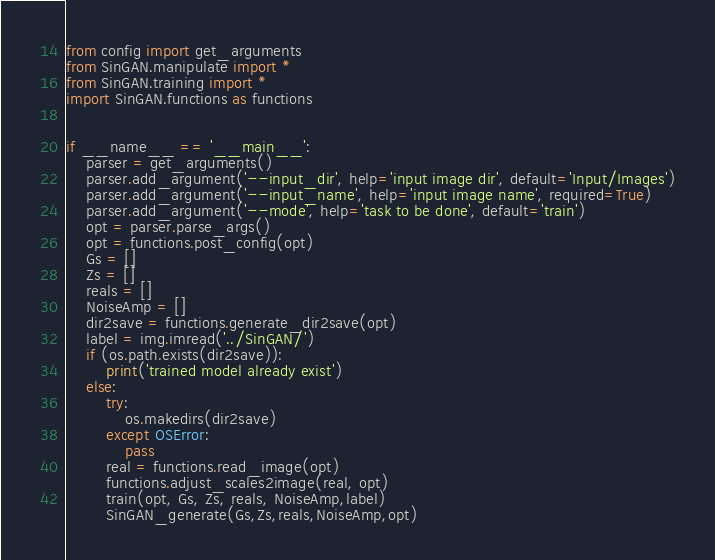<code> <loc_0><loc_0><loc_500><loc_500><_Python_>from config import get_arguments
from SinGAN.manipulate import *
from SinGAN.training import *
import SinGAN.functions as functions


if __name__ == '__main__':
    parser = get_arguments()
    parser.add_argument('--input_dir', help='input image dir', default='Input/Images')
    parser.add_argument('--input_name', help='input image name', required=True)
    parser.add_argument('--mode', help='task to be done', default='train')
    opt = parser.parse_args()
    opt = functions.post_config(opt)
    Gs = []
    Zs = []
    reals = []
    NoiseAmp = []
    dir2save = functions.generate_dir2save(opt)
    label = img.imread('../SinGAN/')
    if (os.path.exists(dir2save)):
        print('trained model already exist')
    else:
        try:
            os.makedirs(dir2save)
        except OSError:
            pass
        real = functions.read_image(opt)
        functions.adjust_scales2image(real, opt)
        train(opt, Gs, Zs, reals, NoiseAmp,label)
        SinGAN_generate(Gs,Zs,reals,NoiseAmp,opt)
</code> 